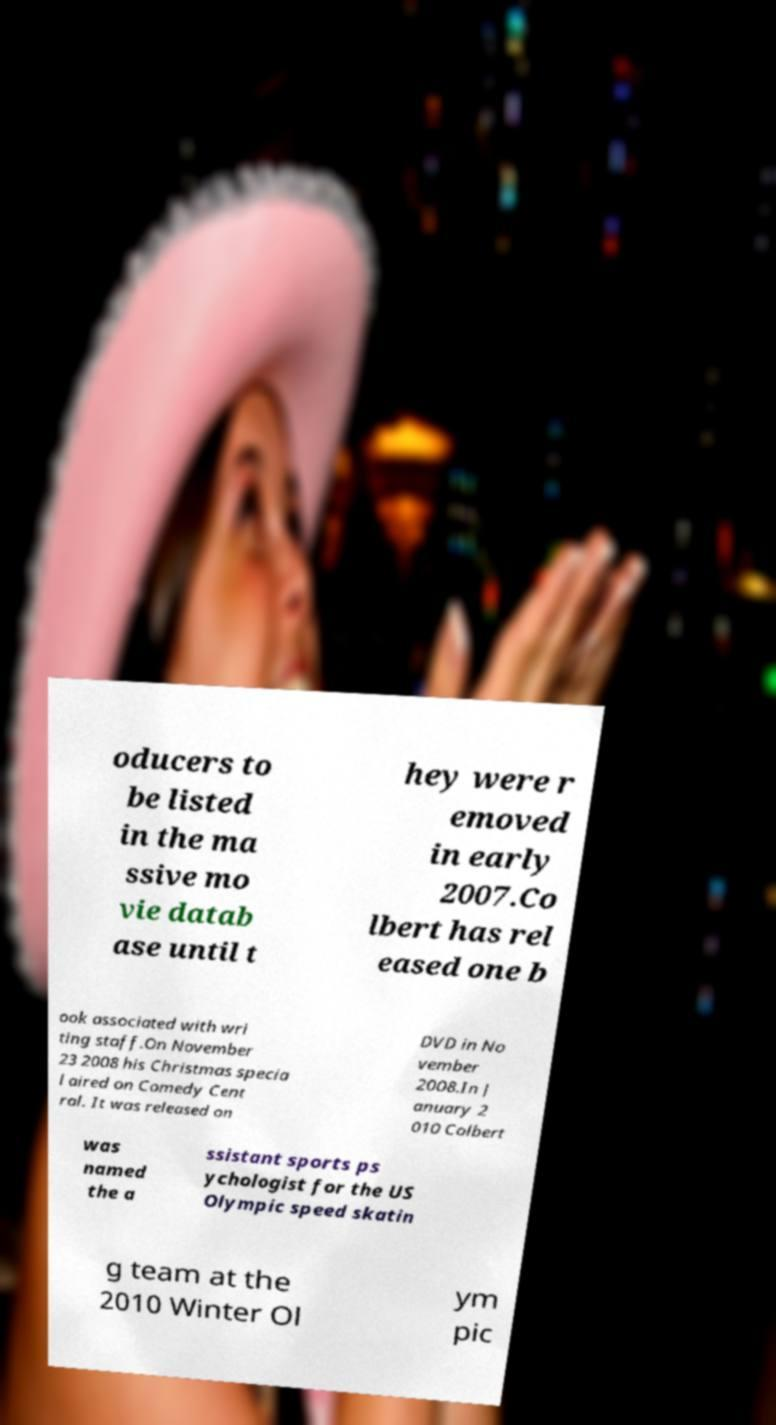Can you accurately transcribe the text from the provided image for me? oducers to be listed in the ma ssive mo vie datab ase until t hey were r emoved in early 2007.Co lbert has rel eased one b ook associated with wri ting staff.On November 23 2008 his Christmas specia l aired on Comedy Cent ral. It was released on DVD in No vember 2008.In J anuary 2 010 Colbert was named the a ssistant sports ps ychologist for the US Olympic speed skatin g team at the 2010 Winter Ol ym pic 